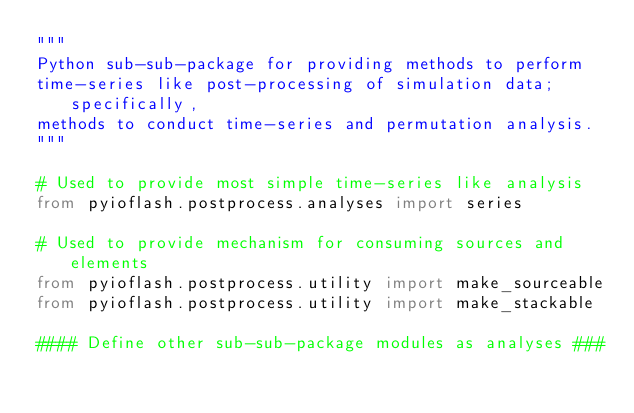Convert code to text. <code><loc_0><loc_0><loc_500><loc_500><_Python_>"""
Python sub-sub-package for providing methods to perform 
time-series like post-processing of simulation data; specifically, 
methods to conduct time-series and permutation analysis.
"""

# Used to provide most simple time-series like analysis 
from pyioflash.postprocess.analyses import series

# Used to provide mechanism for consuming sources and elements
from pyioflash.postprocess.utility import make_sourceable
from pyioflash.postprocess.utility import make_stackable

#### Define other sub-sub-package modules as analyses ###
</code> 